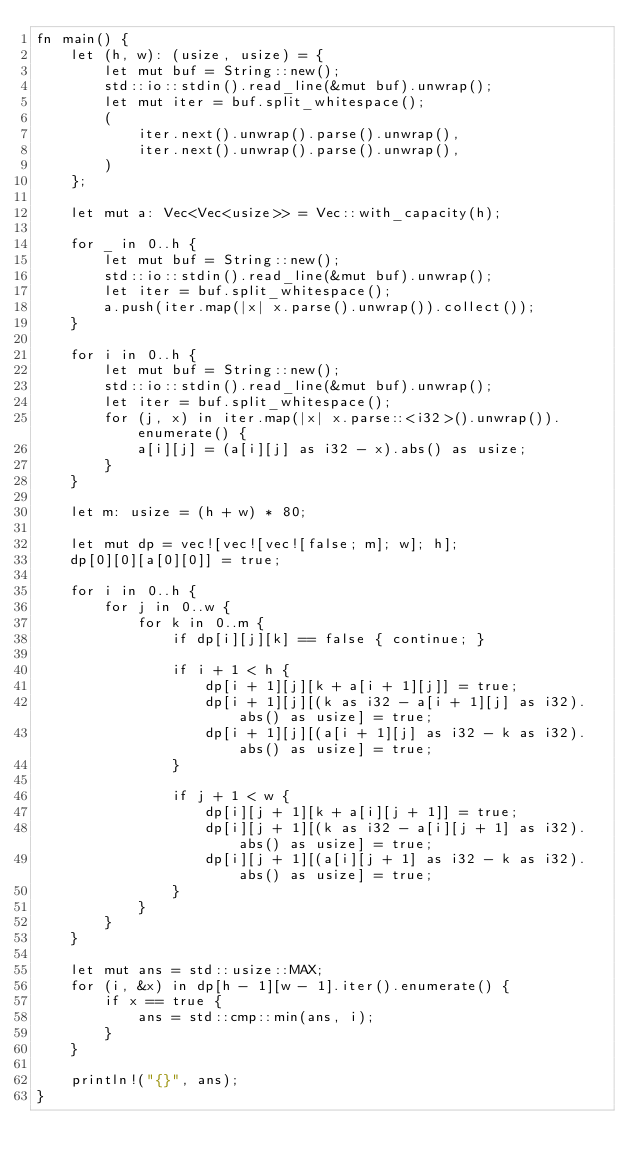Convert code to text. <code><loc_0><loc_0><loc_500><loc_500><_Rust_>fn main() {
    let (h, w): (usize, usize) = {
        let mut buf = String::new();
        std::io::stdin().read_line(&mut buf).unwrap();
        let mut iter = buf.split_whitespace();
        (
            iter.next().unwrap().parse().unwrap(),
            iter.next().unwrap().parse().unwrap(),
        )
    };

    let mut a: Vec<Vec<usize>> = Vec::with_capacity(h);

    for _ in 0..h {
        let mut buf = String::new();
        std::io::stdin().read_line(&mut buf).unwrap();
        let iter = buf.split_whitespace();
        a.push(iter.map(|x| x.parse().unwrap()).collect());
    }

    for i in 0..h {
        let mut buf = String::new();
        std::io::stdin().read_line(&mut buf).unwrap();
        let iter = buf.split_whitespace();
        for (j, x) in iter.map(|x| x.parse::<i32>().unwrap()).enumerate() {
            a[i][j] = (a[i][j] as i32 - x).abs() as usize;
        }
    }

    let m: usize = (h + w) * 80;

    let mut dp = vec![vec![vec![false; m]; w]; h];
    dp[0][0][a[0][0]] = true;

    for i in 0..h {
        for j in 0..w {
            for k in 0..m {
                if dp[i][j][k] == false { continue; }

                if i + 1 < h {
                    dp[i + 1][j][k + a[i + 1][j]] = true;
                    dp[i + 1][j][(k as i32 - a[i + 1][j] as i32).abs() as usize] = true;
                    dp[i + 1][j][(a[i + 1][j] as i32 - k as i32).abs() as usize] = true;
                }

                if j + 1 < w {
                    dp[i][j + 1][k + a[i][j + 1]] = true;
                    dp[i][j + 1][(k as i32 - a[i][j + 1] as i32).abs() as usize] = true;
                    dp[i][j + 1][(a[i][j + 1] as i32 - k as i32).abs() as usize] = true;
                }
            }
        }
    }

    let mut ans = std::usize::MAX;
    for (i, &x) in dp[h - 1][w - 1].iter().enumerate() {
        if x == true {
            ans = std::cmp::min(ans, i);
        }
    }

    println!("{}", ans);
}</code> 